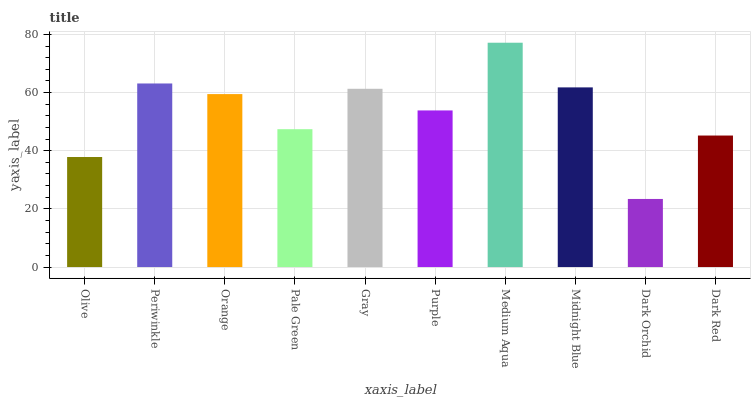Is Dark Orchid the minimum?
Answer yes or no. Yes. Is Medium Aqua the maximum?
Answer yes or no. Yes. Is Periwinkle the minimum?
Answer yes or no. No. Is Periwinkle the maximum?
Answer yes or no. No. Is Periwinkle greater than Olive?
Answer yes or no. Yes. Is Olive less than Periwinkle?
Answer yes or no. Yes. Is Olive greater than Periwinkle?
Answer yes or no. No. Is Periwinkle less than Olive?
Answer yes or no. No. Is Orange the high median?
Answer yes or no. Yes. Is Purple the low median?
Answer yes or no. Yes. Is Purple the high median?
Answer yes or no. No. Is Orange the low median?
Answer yes or no. No. 